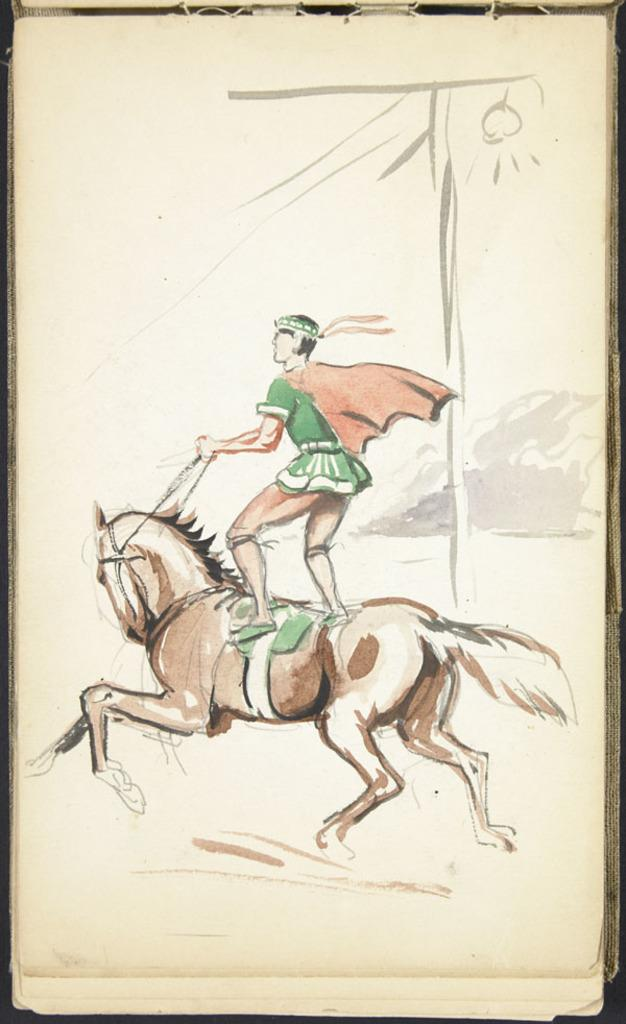Who or what is the main subject in the image? There is a person in the image. What is the person doing in the image? The person is riding a horse. What type of image is it? The image is animated. What type of machine is visible in the image? There is no machine present in the image; it features a person riding a horse in an animated setting. What is the person's opinion about the loaf of bread in the image? There is no loaf of bread present in the image, so it is not possible to determine the person's opinion about it. 